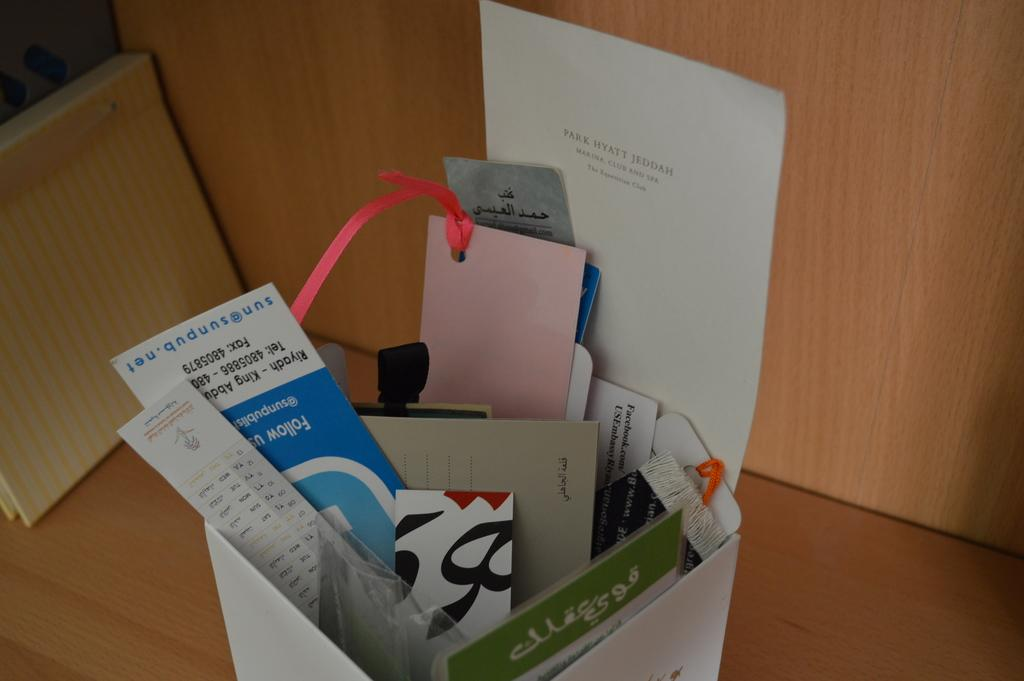<image>
Summarize the visual content of the image. A piece of paper displays the text 'Park Hyatt Jeddah'. 